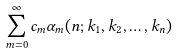Convert formula to latex. <formula><loc_0><loc_0><loc_500><loc_500>\sum _ { m = 0 } ^ { \infty } c _ { m } \alpha _ { m } ( n ; k _ { 1 } , k _ { 2 } , \dots , k _ { n } )</formula> 